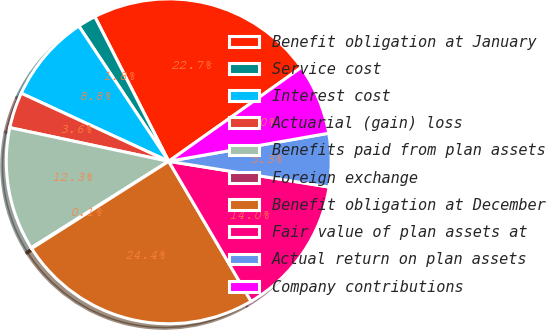Convert chart to OTSL. <chart><loc_0><loc_0><loc_500><loc_500><pie_chart><fcel>Benefit obligation at January<fcel>Service cost<fcel>Interest cost<fcel>Actuarial (gain) loss<fcel>Benefits paid from plan assets<fcel>Foreign exchange<fcel>Benefit obligation at December<fcel>Fair value of plan assets at<fcel>Actual return on plan assets<fcel>Company contributions<nl><fcel>22.71%<fcel>1.82%<fcel>8.78%<fcel>3.56%<fcel>12.26%<fcel>0.08%<fcel>24.45%<fcel>14.0%<fcel>5.3%<fcel>7.04%<nl></chart> 